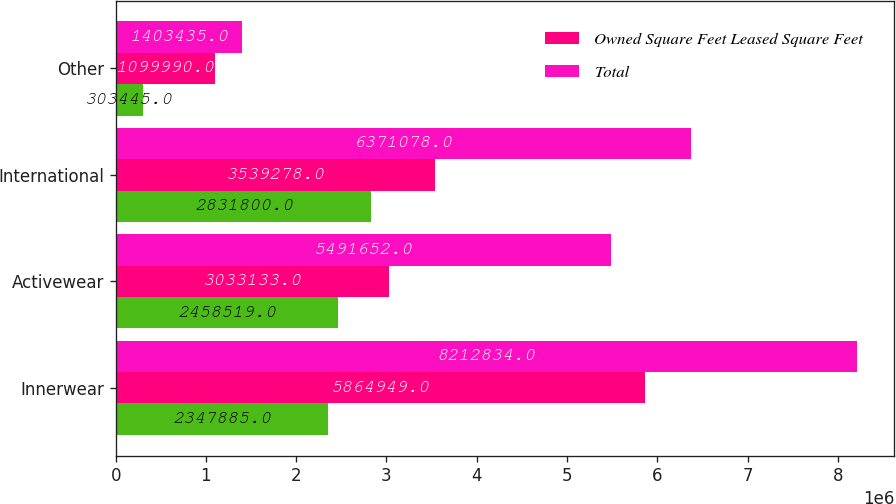Convert chart to OTSL. <chart><loc_0><loc_0><loc_500><loc_500><stacked_bar_chart><ecel><fcel>Innerwear<fcel>Activewear<fcel>International<fcel>Other<nl><fcel>nan<fcel>2.34788e+06<fcel>2.45852e+06<fcel>2.8318e+06<fcel>303445<nl><fcel>Owned Square Feet Leased Square Feet<fcel>5.86495e+06<fcel>3.03313e+06<fcel>3.53928e+06<fcel>1.09999e+06<nl><fcel>Total<fcel>8.21283e+06<fcel>5.49165e+06<fcel>6.37108e+06<fcel>1.40344e+06<nl></chart> 